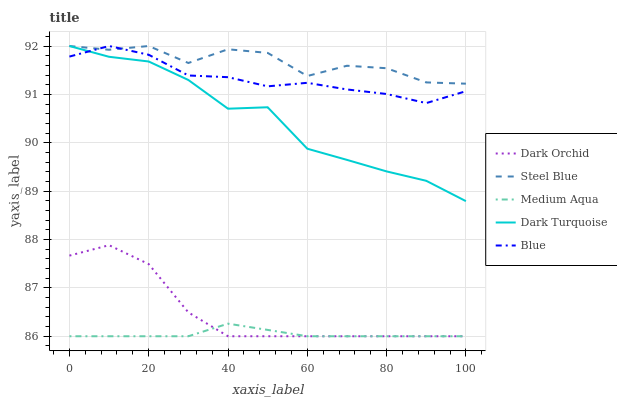Does Dark Turquoise have the minimum area under the curve?
Answer yes or no. No. Does Dark Turquoise have the maximum area under the curve?
Answer yes or no. No. Is Dark Turquoise the smoothest?
Answer yes or no. No. Is Dark Turquoise the roughest?
Answer yes or no. No. Does Dark Turquoise have the lowest value?
Answer yes or no. No. Does Medium Aqua have the highest value?
Answer yes or no. No. Is Medium Aqua less than Steel Blue?
Answer yes or no. Yes. Is Steel Blue greater than Dark Orchid?
Answer yes or no. Yes. Does Medium Aqua intersect Steel Blue?
Answer yes or no. No. 